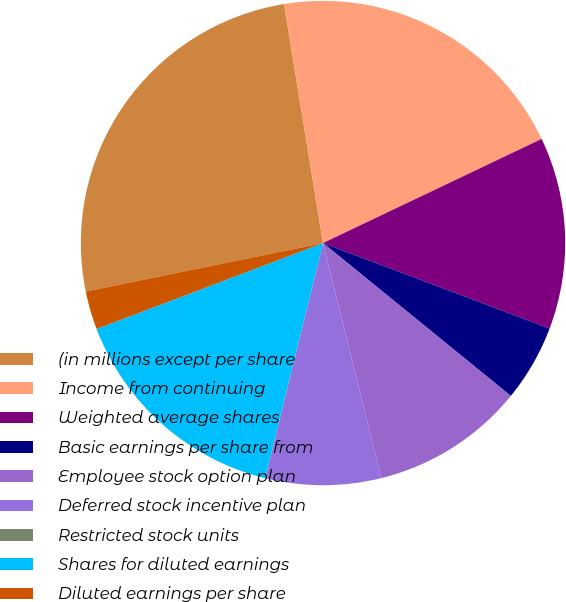Convert chart. <chart><loc_0><loc_0><loc_500><loc_500><pie_chart><fcel>(in millions except per share<fcel>Income from continuing<fcel>Weighted average shares<fcel>Basic earnings per share from<fcel>Employee stock option plan<fcel>Deferred stock incentive plan<fcel>Restricted stock units<fcel>Shares for diluted earnings<fcel>Diluted earnings per share<nl><fcel>25.63%<fcel>20.5%<fcel>12.82%<fcel>5.13%<fcel>10.26%<fcel>7.7%<fcel>0.01%<fcel>15.38%<fcel>2.57%<nl></chart> 